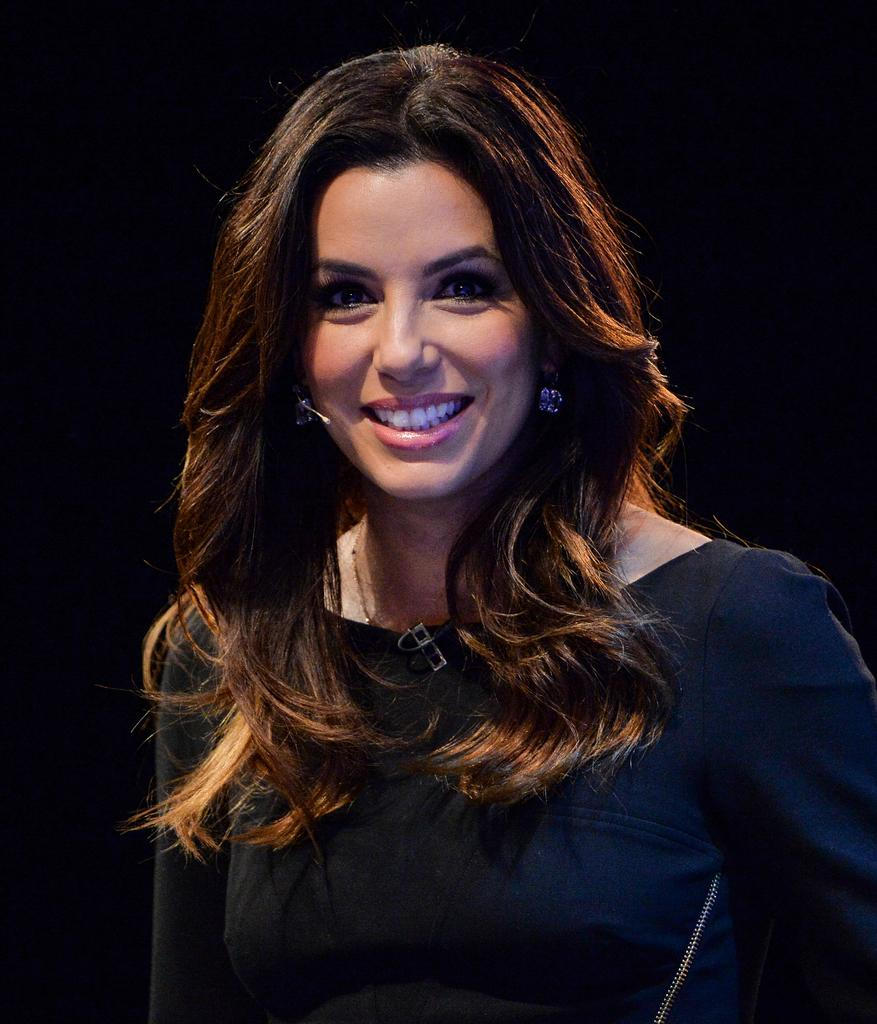Who is present in the image? There is a woman in the image. What type of zinc is the woman using to stamp a reason in the image? There is no zinc or stamping activity present in the image; it only features a woman. 